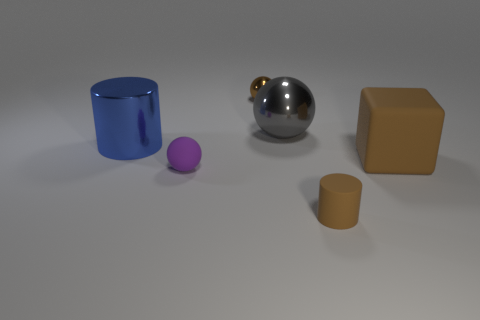What number of other small metallic objects are the same shape as the gray object?
Your response must be concise. 1. Do the large blue object and the big gray thing have the same shape?
Give a very brief answer. No. What number of things are small matte things behind the tiny brown matte object or small brown metallic things?
Your response must be concise. 2. The brown thing that is in front of the large thing on the right side of the cylinder right of the big metallic cylinder is what shape?
Make the answer very short. Cylinder. What shape is the gray thing that is the same material as the brown sphere?
Your answer should be compact. Sphere. The matte ball is what size?
Offer a terse response. Small. Do the gray metallic object and the purple rubber ball have the same size?
Keep it short and to the point. No. How many things are either small matte things to the left of the small brown shiny ball or large objects behind the brown cube?
Provide a short and direct response. 3. There is a large shiny thing right of the tiny ball that is in front of the gray shiny thing; what number of brown rubber things are in front of it?
Provide a succinct answer. 2. What is the size of the brown object that is behind the large blue shiny cylinder?
Provide a succinct answer. Small. 